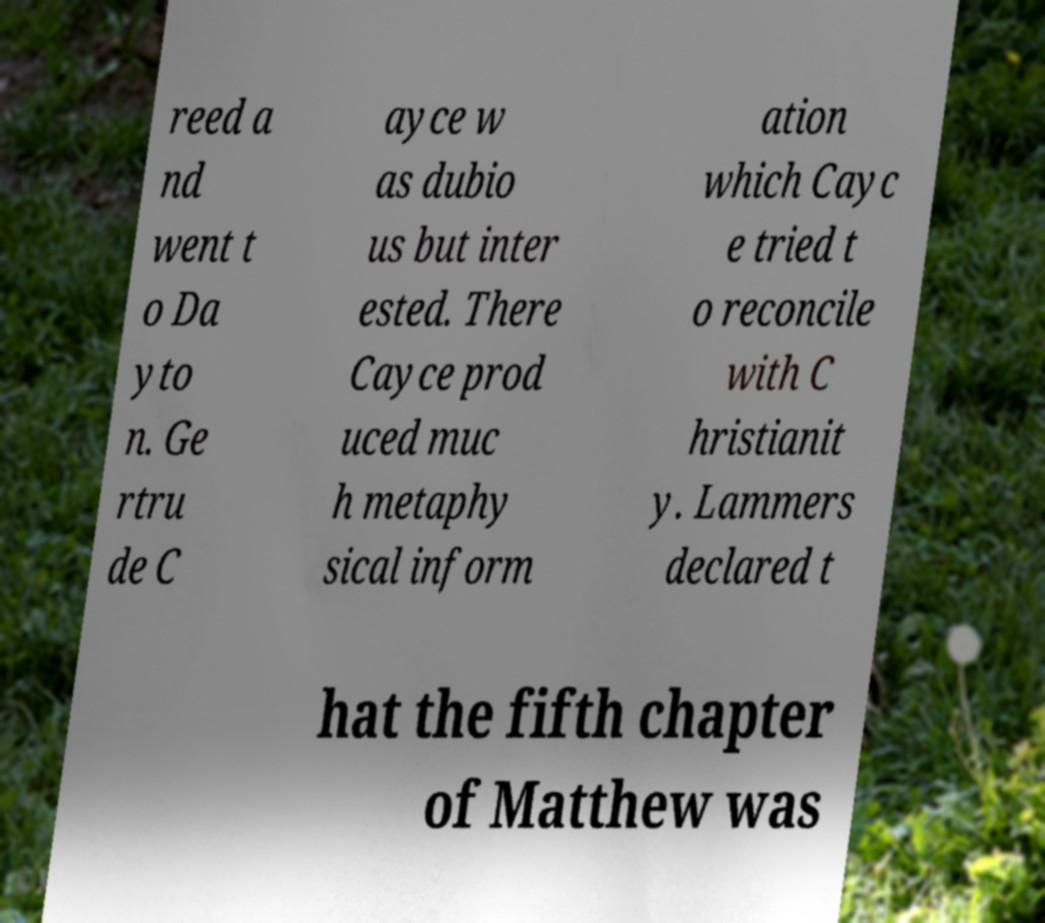What messages or text are displayed in this image? I need them in a readable, typed format. reed a nd went t o Da yto n. Ge rtru de C ayce w as dubio us but inter ested. There Cayce prod uced muc h metaphy sical inform ation which Cayc e tried t o reconcile with C hristianit y. Lammers declared t hat the fifth chapter of Matthew was 